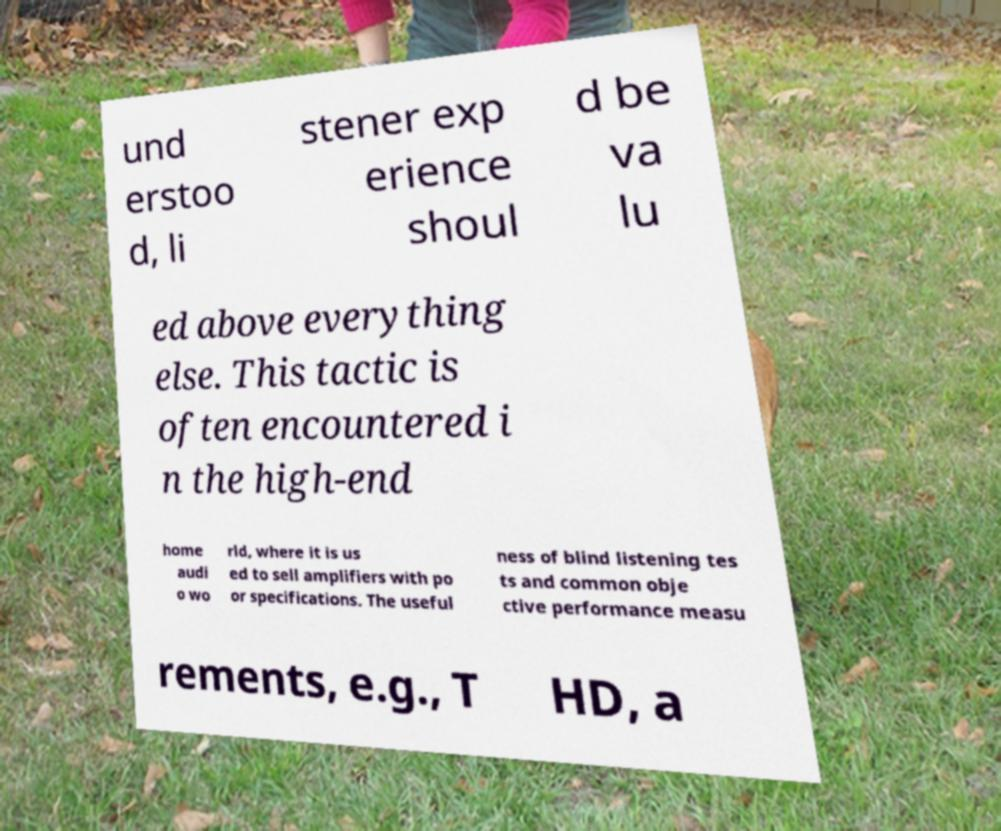For documentation purposes, I need the text within this image transcribed. Could you provide that? und erstoo d, li stener exp erience shoul d be va lu ed above everything else. This tactic is often encountered i n the high-end home audi o wo rld, where it is us ed to sell amplifiers with po or specifications. The useful ness of blind listening tes ts and common obje ctive performance measu rements, e.g., T HD, a 